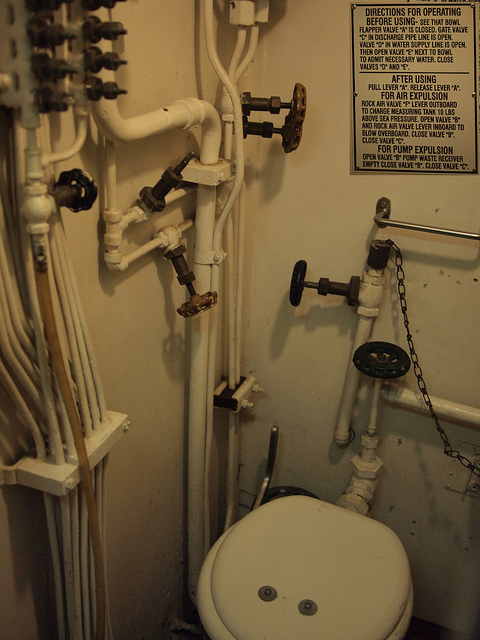Read all the text in this image. AFTER USING FOR AIR EXPULSION EMPTY CLOSE VALVE B CLOSE YILYE C RECEIVER WASTE OPEN FOR PUMP EXPULSION CLOSE NO VAUE LEVER INBOARD PRESSURE SEA ABOVE CHARGE MEASURING TANK CUTBOARD LEVER AIR ROCK LEVER SELLEASE LEVER PULL TO NECESSARY WATER CLOSE BOWL NEXT THEN VALUE WATER SUPPLY LINE OPEN DISCHARGE FLAPPER CLOSED GATE BOWL THAT SEE USING BEFORE OPERATING FOR DIRECTIONS 